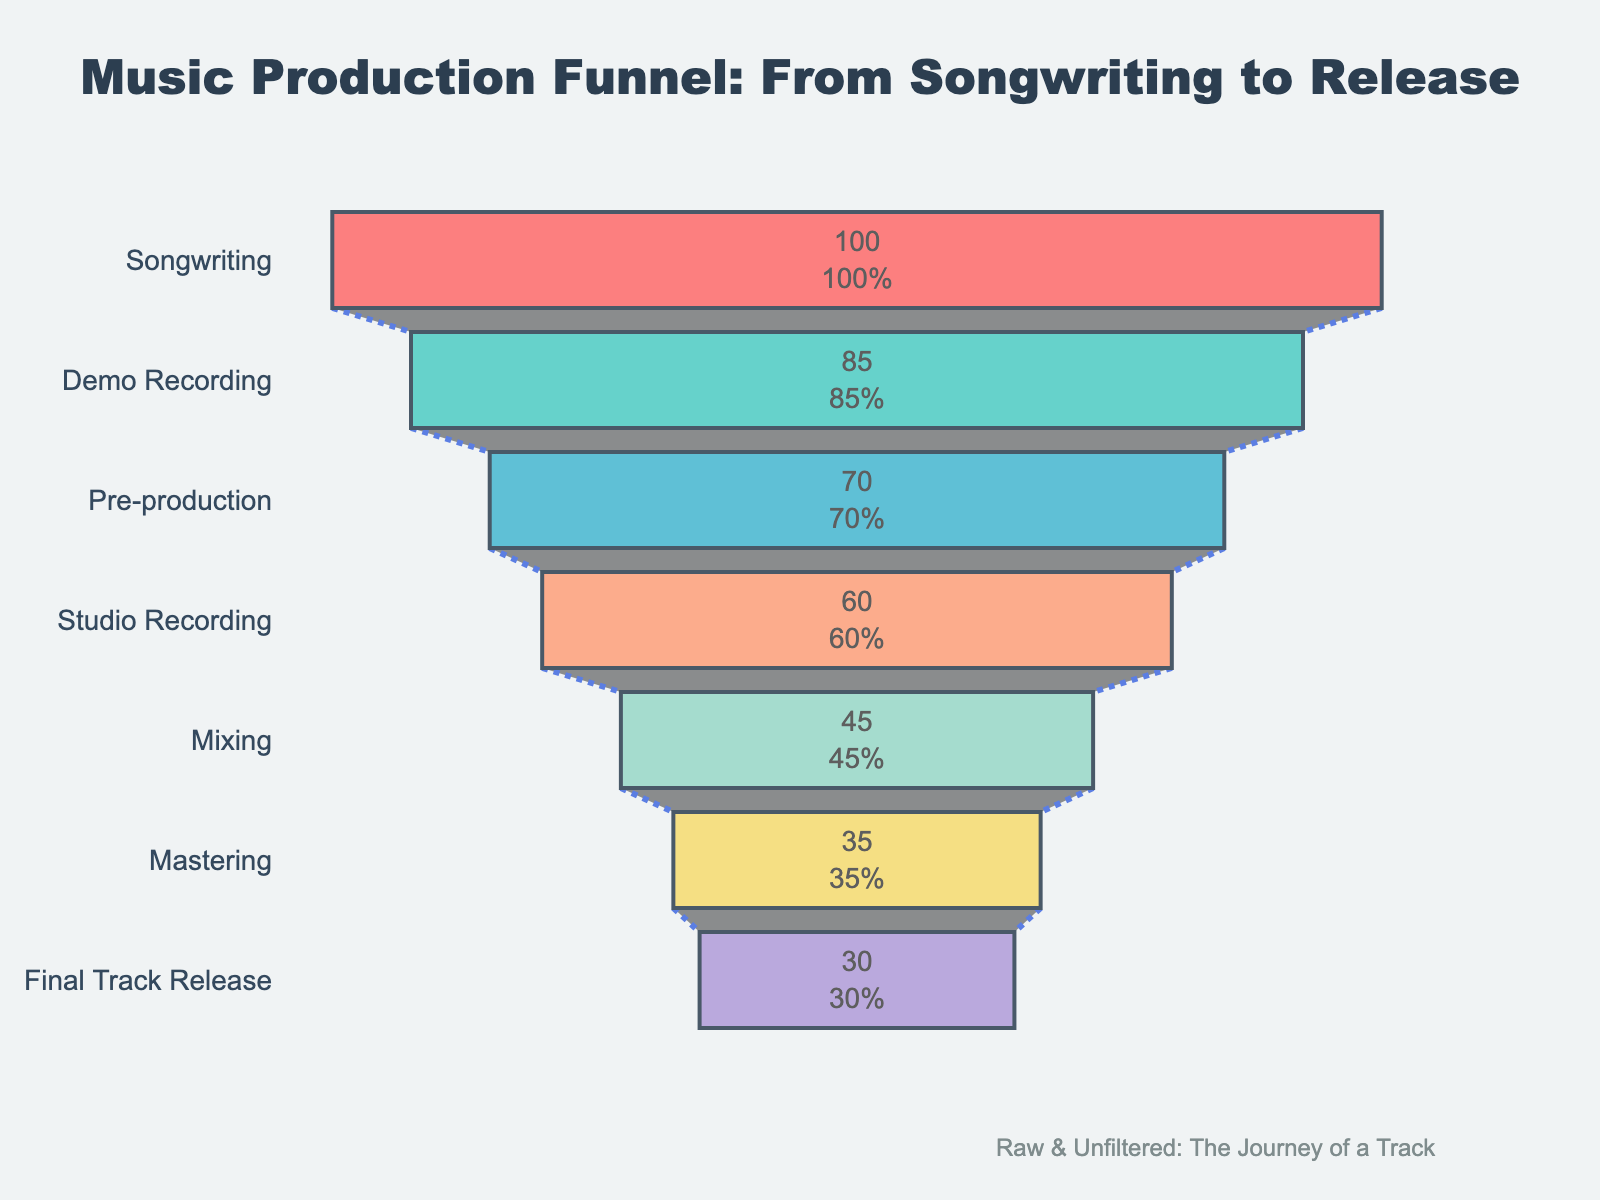what's the title of the figure? The title can be found at the top of the figure. It reads "Music Production Funnel: From Songwriting to Release".
Answer: Music Production Funnel: From Songwriting to Release How many stages are depicted in the figure? Each stage corresponds to a horizontal section of the funnel. Counting these sections gives the total number of stages, which is 7.
Answer: 7 Which stage has the highest completion rate? Looking at the funnel, the topmost stage represents the highest completion rate. This stage is "Songwriting".
Answer: Songwriting What's the difference in completion rates between "Songwriting" and "Final Track Release"? The completion rate for "Songwriting" is 100%, and for "Final Track Release" is 30%. The difference is 100 - 30 = 70%.
Answer: 70% What is the completion rate after pre-production? According to the funnel, "Pre-production" has a 70% completion rate. The stage immediately after is "Studio Recording" with a 60% completion rate.
Answer: 60% Which stage shows the largest drop in completion rate compared to its prior stage? By comparing the completion rates of consecutive stages, we find that the largest drop is between "Songwriting" (100%) and "Demo Recording" (85%), which is a 15% drop.
Answer: Songwriting to Demo Recording Is there any stage with a completion rate below 40%? Observing the funnel, the stages with completion rates below 40% are both "Mastering" (35%) and "Final Track Release" (30%).
Answer: Yes Among 'Mixing' and 'Mastering', which stage has a higher completion rate? The completion rate for "Mixing" is 45%, while for "Mastering" is 35%. So, "Mixing" has a higher completion rate.
Answer: Mixing By how much does the completion rate drop from "Mixing" to "Final Track Release"? The completion rate for "Mixing" is 45% and for "Final Track Release" is 30%. The drop is 45 - 30 = 15%.
Answer: 15% What percentage of initial completion is retained at the studio recording stage? "Studio Recording" has a 60% completion rate and the initial rate is 100%. Therefore, the percentage retained is (60/100)*100 = 60%.
Answer: 60% 